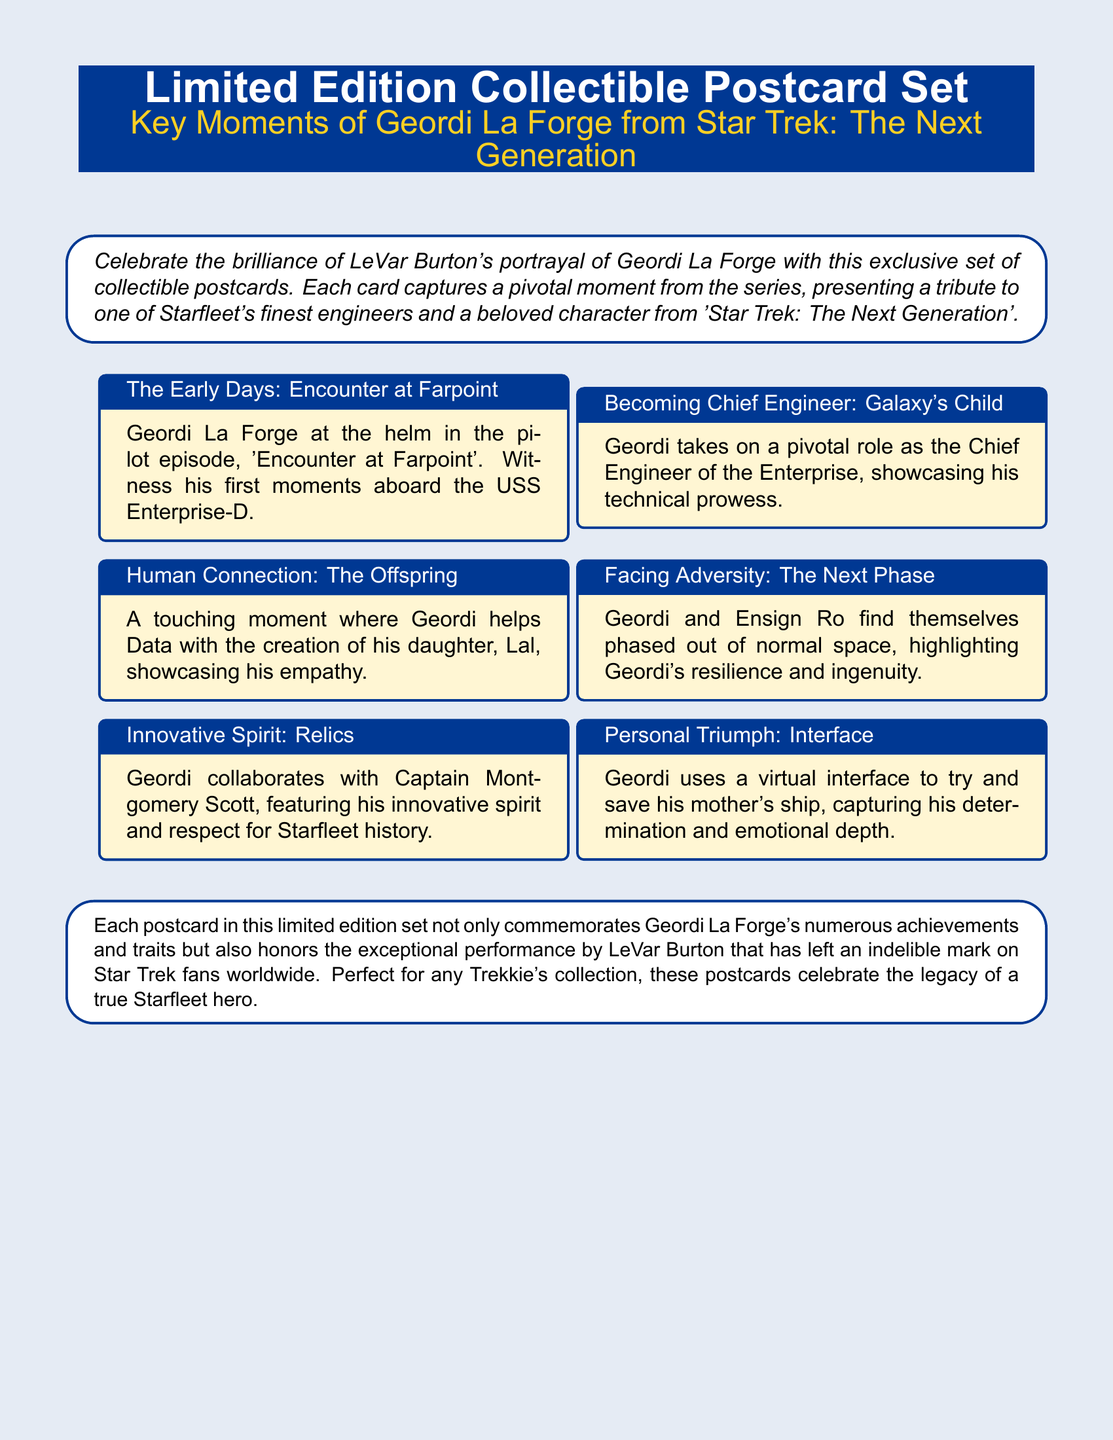What is the title of the postcard set? The title of the postcard set is presented prominently at the top of the document.
Answer: Limited Edition Collectible Postcard Set Who is depicted in this postcard set? The document states that the set depicts a character from Star Trek: The Next Generation.
Answer: Geordi La Forge What is Geordi's role in 'Star Trek: The Next Generation'? The document describes Geordi La Forge's profession within the series to highlight his contributions.
Answer: Chief Engineer What moment is featured in the postcard titled "Human Connection"? The title specifies the key moment that Geordi is involved in, relating to another character in the series.
Answer: Helping Data with the creation of his daughter, Lal How many postcards are included in the set? The document mentions each postcard commemorates various moments, indicating the extent of the collection.
Answer: Limited edition set (exact number not given) What episode features Geordi at the helm in "The Early Days"? The title of the postcard box provides the episode name where this event occurs.
Answer: Encounter at Farpoint What quality does Geordi display in "Facing Adversity"? The description outlines how Geordi handles challenges during this episode.
Answer: Resilience and ingenuity Who is Geordi collaborating with in "Innovative Spirit"? The card titles indicate another iconic character from Star Trek involved in this moment.
Answer: Captain Montgomery Scott 